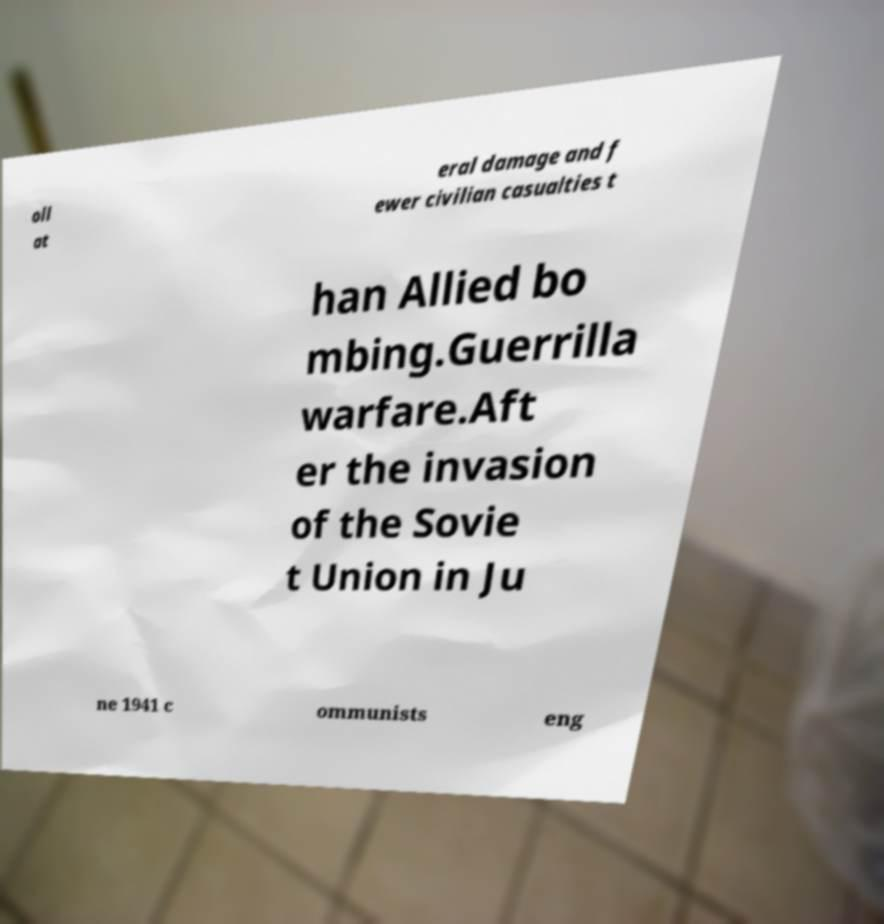There's text embedded in this image that I need extracted. Can you transcribe it verbatim? oll at eral damage and f ewer civilian casualties t han Allied bo mbing.Guerrilla warfare.Aft er the invasion of the Sovie t Union in Ju ne 1941 c ommunists eng 